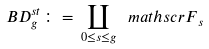<formula> <loc_0><loc_0><loc_500><loc_500>\ B D _ { g } ^ { s t } \colon = \, \coprod _ { 0 \leq s \leq g } { \ m a t h s c r F } _ { s }</formula> 